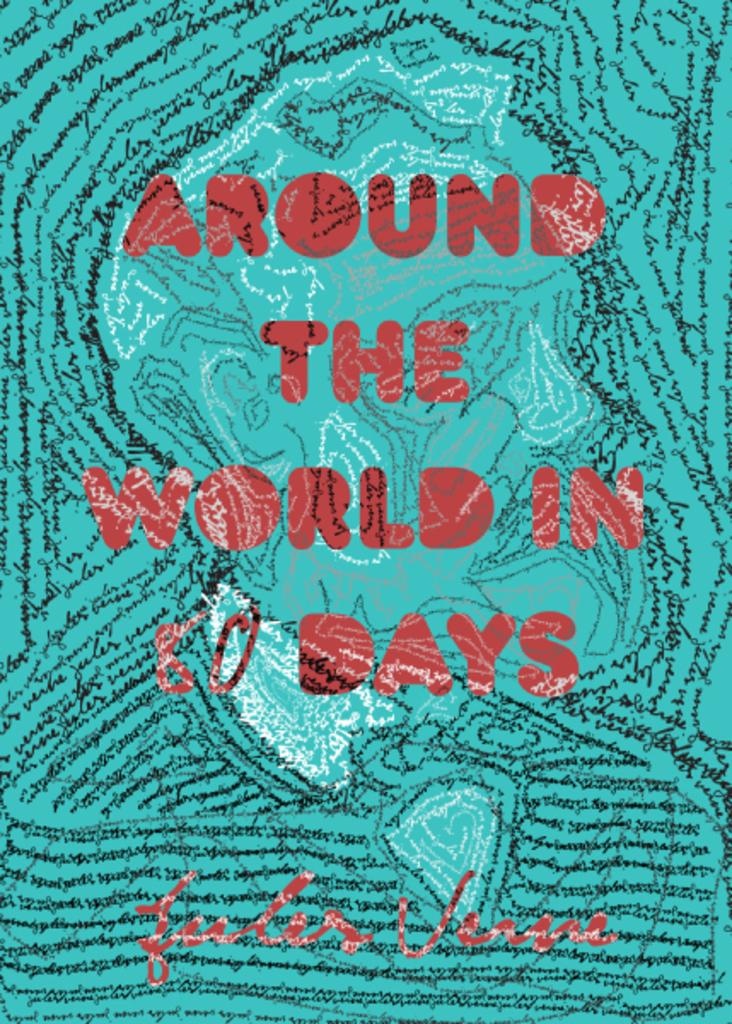<image>
Share a concise interpretation of the image provided. The book Around the World in 80 Days. 